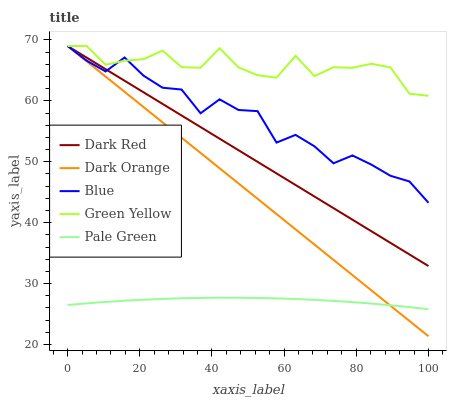Does Pale Green have the minimum area under the curve?
Answer yes or no. Yes. Does Green Yellow have the maximum area under the curve?
Answer yes or no. Yes. Does Dark Red have the minimum area under the curve?
Answer yes or no. No. Does Dark Red have the maximum area under the curve?
Answer yes or no. No. Is Dark Orange the smoothest?
Answer yes or no. Yes. Is Green Yellow the roughest?
Answer yes or no. Yes. Is Dark Red the smoothest?
Answer yes or no. No. Is Dark Red the roughest?
Answer yes or no. No. Does Dark Orange have the lowest value?
Answer yes or no. Yes. Does Dark Red have the lowest value?
Answer yes or no. No. Does Dark Orange have the highest value?
Answer yes or no. Yes. Does Pale Green have the highest value?
Answer yes or no. No. Is Pale Green less than Dark Red?
Answer yes or no. Yes. Is Dark Red greater than Pale Green?
Answer yes or no. Yes. Does Green Yellow intersect Dark Red?
Answer yes or no. Yes. Is Green Yellow less than Dark Red?
Answer yes or no. No. Is Green Yellow greater than Dark Red?
Answer yes or no. No. Does Pale Green intersect Dark Red?
Answer yes or no. No. 